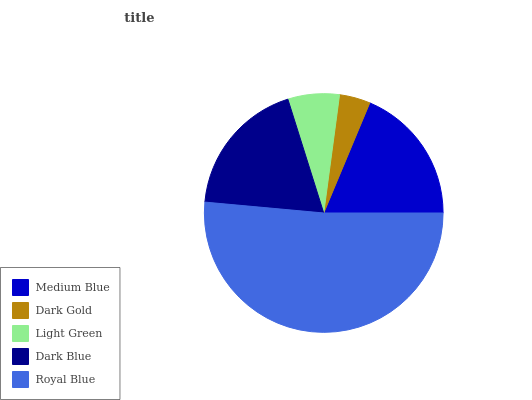Is Dark Gold the minimum?
Answer yes or no. Yes. Is Royal Blue the maximum?
Answer yes or no. Yes. Is Light Green the minimum?
Answer yes or no. No. Is Light Green the maximum?
Answer yes or no. No. Is Light Green greater than Dark Gold?
Answer yes or no. Yes. Is Dark Gold less than Light Green?
Answer yes or no. Yes. Is Dark Gold greater than Light Green?
Answer yes or no. No. Is Light Green less than Dark Gold?
Answer yes or no. No. Is Dark Blue the high median?
Answer yes or no. Yes. Is Dark Blue the low median?
Answer yes or no. Yes. Is Dark Gold the high median?
Answer yes or no. No. Is Dark Gold the low median?
Answer yes or no. No. 